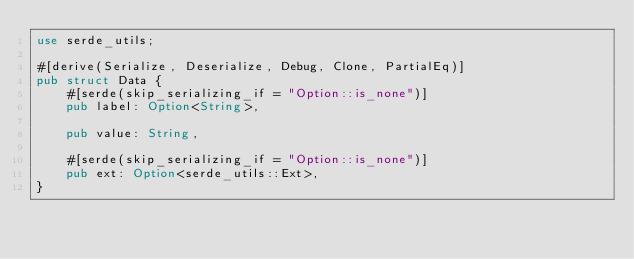Convert code to text. <code><loc_0><loc_0><loc_500><loc_500><_Rust_>use serde_utils;

#[derive(Serialize, Deserialize, Debug, Clone, PartialEq)]
pub struct Data {
    #[serde(skip_serializing_if = "Option::is_none")]
    pub label: Option<String>,

    pub value: String,

    #[serde(skip_serializing_if = "Option::is_none")]
    pub ext: Option<serde_utils::Ext>,
}
</code> 